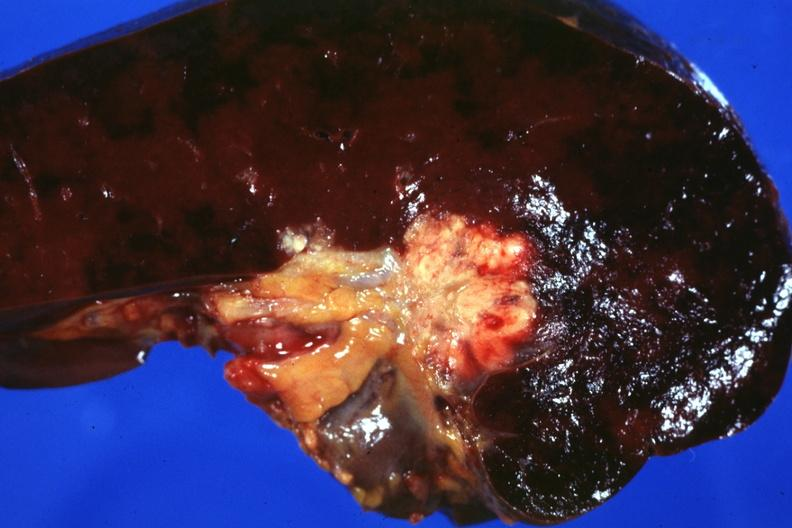what is present?
Answer the question using a single word or phrase. Hematologic 